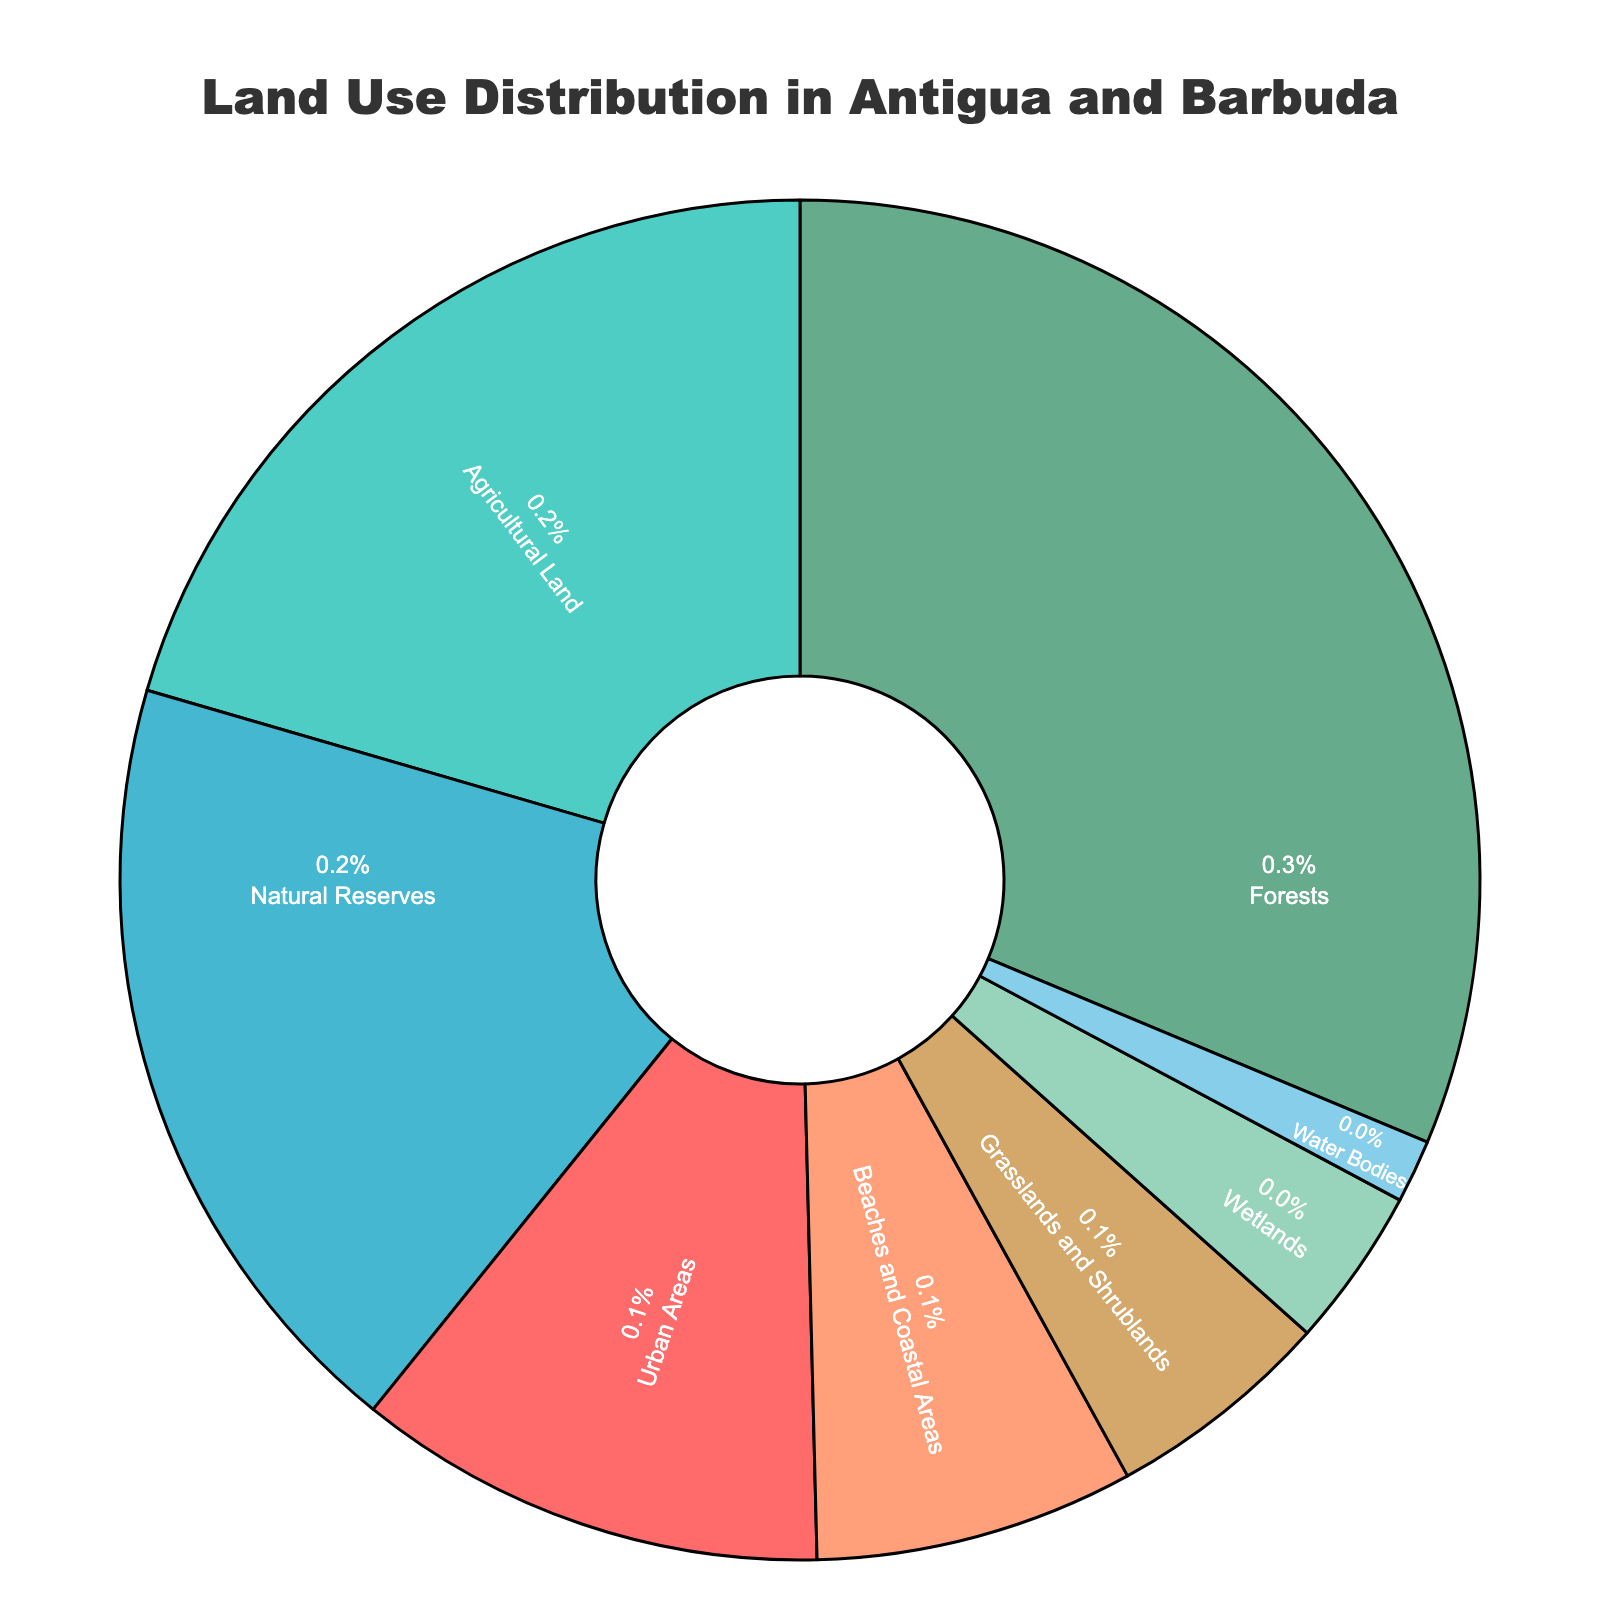What percentage of land in Antigua and Barbuda is used for urban areas, agricultural land, and natural reserves combined? The percentages for urban areas, agricultural land, and natural reserves are 11.2%, 20.5%, and 18.7% respectively. Adding these together gives 11.2 + 20.5 + 18.7 = 50.4%.
Answer: 50.4% Which land use category occupies the largest portion of Antigua and Barbuda? The category with the largest percentage on the pie chart is labeled as "Forests" with 31.3%.
Answer: Forests How does the percentage of beaches and coastal areas compare to that of wetlands? The percentage for beaches and coastal areas is 7.6%, while for wetlands it is 3.8%. Since 7.6% is greater than 3.8%, beaches and coastal areas occupy a larger portion.
Answer: Beaches and coastal areas occupy a larger portion If you combine grasslands and shrublands with agricultural land, what is their total land use percentage? Grasslands and shrublands occupy 5.4% and agricultural land occupies 20.5%. Adding these together gives 5.4 + 20.5 = 25.9%.
Answer: 25.9% What land use category is represented by the bright green color on the pie chart? Upon examining the colors on the pie chart, the bright green segment represents "Forests."
Answer: Forests Which two land use categories together, excluding forests, make up the second-largest combined portion? Excluding forests, agricultural land (20.5%) and natural reserves (18.7%) together make up the second-largest combined portion. Adding these gives 20.5 + 18.7 = 39.2%.
Answer: Agricultural Land and Natural Reserves What percentage of land is covered by water bodies on the pie chart? The segment labeled as "Water Bodies" indicates a coverage percentage of 1.5%.
Answer: 1.5% Is the land area allocated to agricultural land more or less than double that of natural reserves? Agricultural land has 20.5% while natural reserves have 18.7%. Doubling the natural reserves' percentage gives 2 * 18.7 = 37.4%, which is greater than 20.5%. So, agricultural land is less than double of natural reserves.
Answer: Less than double 